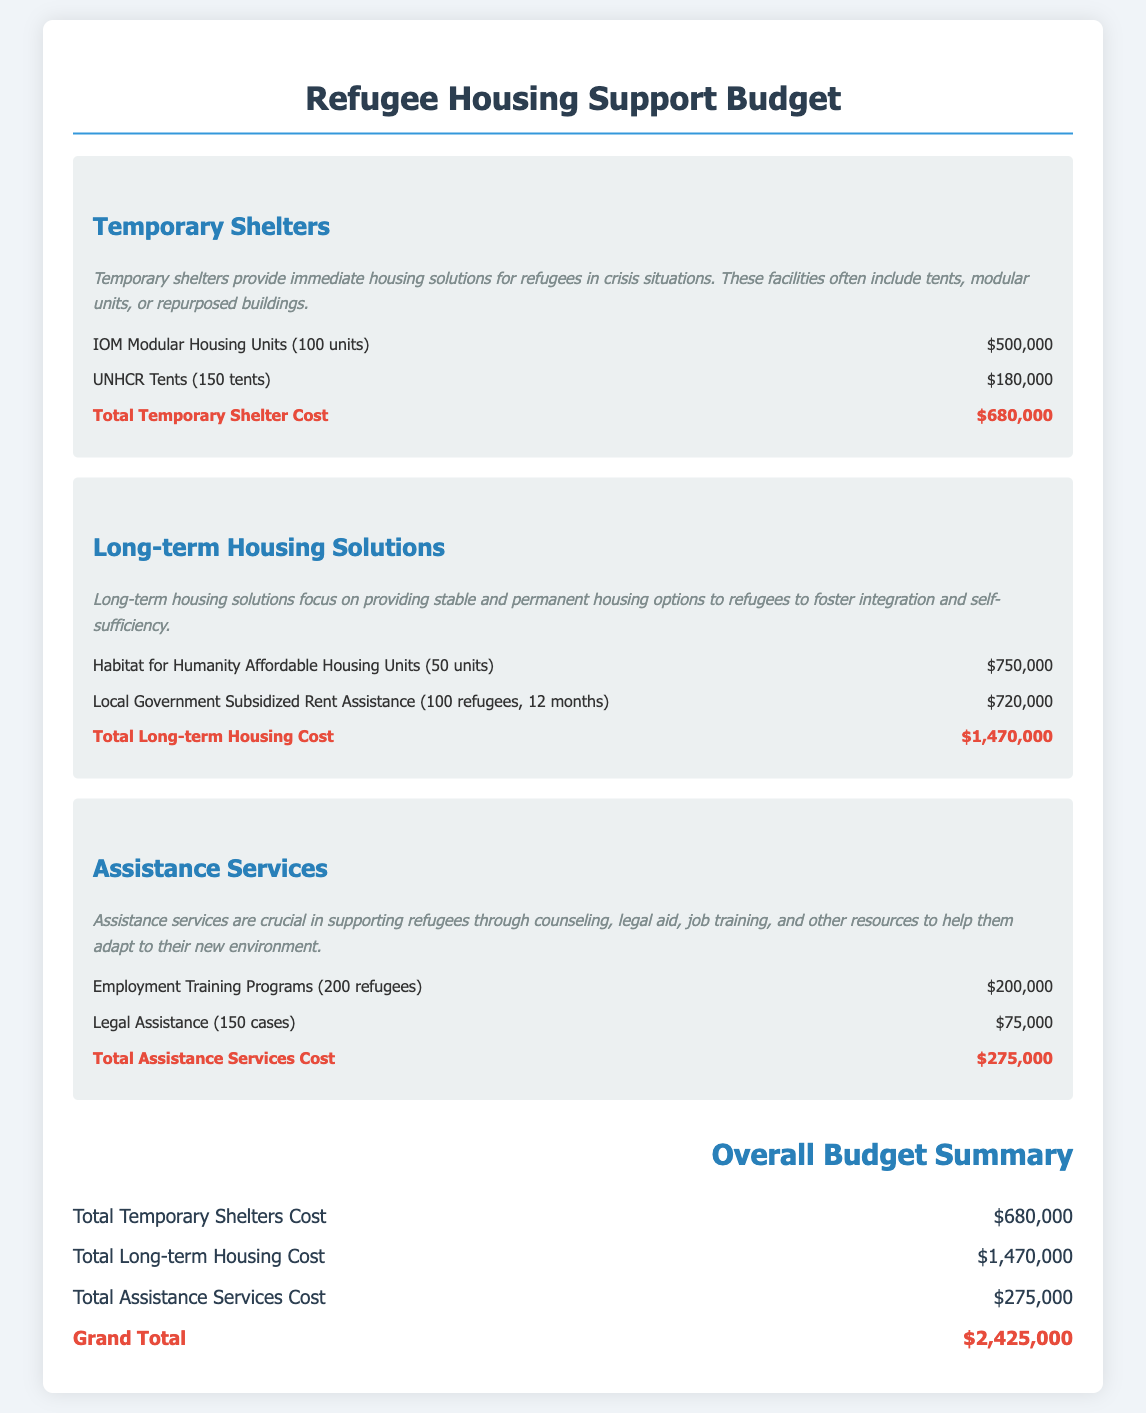What is the total cost for temporary shelters? The total cost for temporary shelters is listed in the budget section.
Answer: $680,000 How many Habitat for Humanity affordable housing units are included? The document specifies the number of units for long-term housing solutions.
Answer: 50 units What is the total cost for assistance services? The total cost for assistance services can be found at the end of the relevant section.
Answer: $275,000 What is the grand total budget for refugee housing support? The grand total is the sum of all the costs presented in the budget.
Answer: $2,425,000 How many refugees are covered by the employment training programs? The document provides specific figures for the program enrollment in the assistance services section.
Answer: 200 refugees What type of shelter is included for temporary housing? The budget details the types of temporary housing being funded.
Answer: Modular Housing Units What is the total cost of local government subsidized rent assistance? This figure is included in the long-term housing solutions section of the budget.
Answer: $720,000 How many UNHCR tents are planned for temporary shelters? The number of tents is mentioned in the temporary shelters section.
Answer: 150 tents What is the cost of legal assistance for refugees? The budget specifies the expenditure allocated to legal assistance under the assistance services category.
Answer: $75,000 